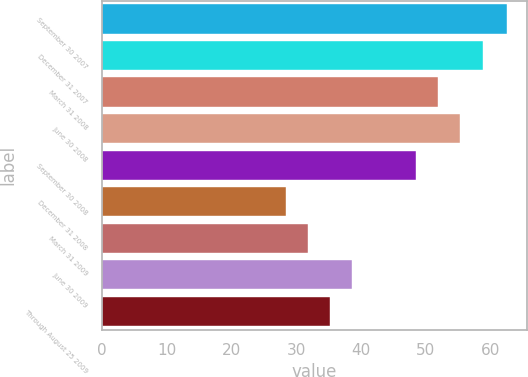Convert chart to OTSL. <chart><loc_0><loc_0><loc_500><loc_500><bar_chart><fcel>September 30 2007<fcel>December 31 2007<fcel>March 31 2008<fcel>June 30 2008<fcel>September 30 2008<fcel>December 31 2008<fcel>March 31 2009<fcel>June 30 2009<fcel>Through August 25 2009<nl><fcel>62.53<fcel>58.78<fcel>51.95<fcel>55.37<fcel>48.54<fcel>28.38<fcel>31.8<fcel>38.63<fcel>35.22<nl></chart> 